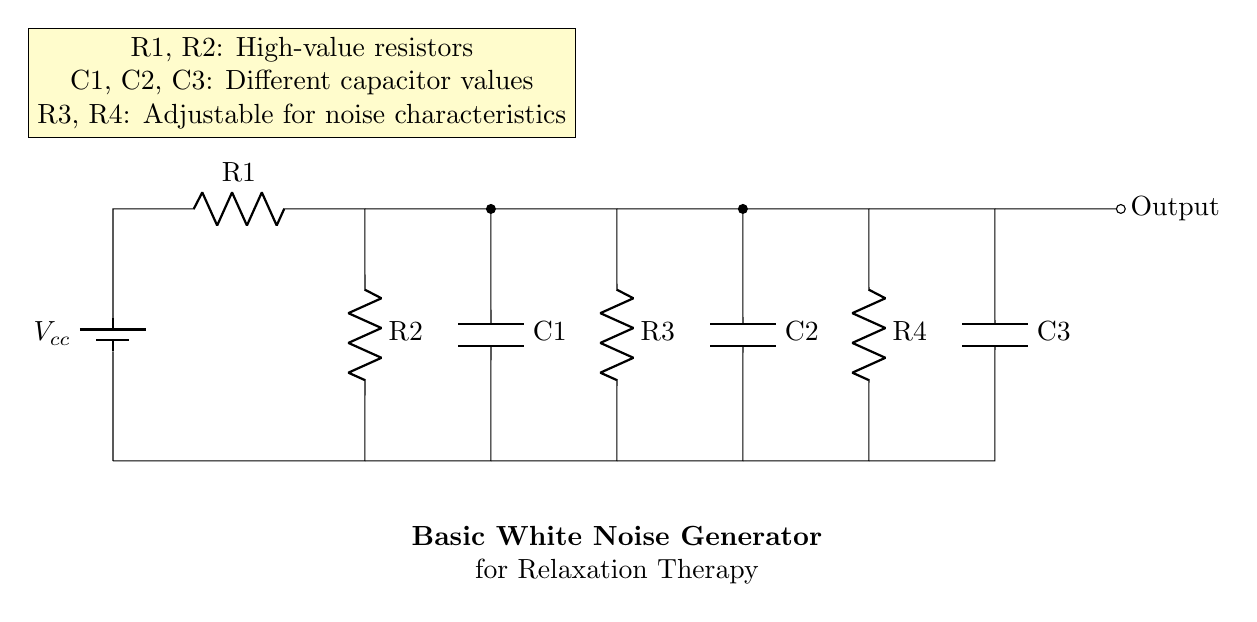What type of circuit is this? This circuit is a noise generator circuit, specifically designed to produce white noise for relaxation therapy. This is inferred from the title on the circuit diagram as well as the arrangement of components that suggest sound generation.
Answer: White noise generator How many resistors are in the circuit? There are four resistors labeled as R1, R2, R3, and R4, indicated in the circuit diagram. Each of these components is denoted clearly.
Answer: Four What do the capacitors in the circuit do? The capacitors C1, C2, and C3 function to filter signals and create the desired noise characteristics by accumulating and releasing charge, which affects the overall output sound. This function is crucial in shaping the type of noise the circuit produces.
Answer: Filter signals What is the output of this circuit? The output of this circuit is labeled as 'Output' and is located at the end of the circuit diagram, indicating where the generated white noise will be delivered.
Answer: Generated noise Which component values are adjustable? The resistors R3 and R4 are adjustable, as noted in the description, which allows for tuning the circuit for different noise characteristics based on the application. This adjustability is important in customizing the noise output.
Answer: R3, R4 What is the voltage supply for this circuit? The voltage supply for this circuit is indicated by the battery symbol labeled as Vcc at the top of the diagram. This is the source that powers the entire circuit.
Answer: Vcc What is the purpose of R1 and R2? Resistors R1 and R2 are high-value resistors, intended primarily to limit current and influence the noise generation characteristics by their resistance values. Their specific roles are essential for ensuring the circuit functions efficiently while generating noise.
Answer: Limit current 